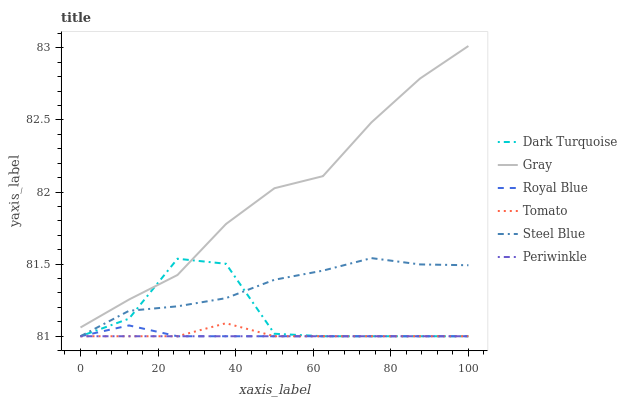Does Periwinkle have the minimum area under the curve?
Answer yes or no. Yes. Does Gray have the maximum area under the curve?
Answer yes or no. Yes. Does Dark Turquoise have the minimum area under the curve?
Answer yes or no. No. Does Dark Turquoise have the maximum area under the curve?
Answer yes or no. No. Is Periwinkle the smoothest?
Answer yes or no. Yes. Is Dark Turquoise the roughest?
Answer yes or no. Yes. Is Gray the smoothest?
Answer yes or no. No. Is Gray the roughest?
Answer yes or no. No. Does Tomato have the lowest value?
Answer yes or no. Yes. Does Gray have the lowest value?
Answer yes or no. No. Does Gray have the highest value?
Answer yes or no. Yes. Does Dark Turquoise have the highest value?
Answer yes or no. No. Is Royal Blue less than Gray?
Answer yes or no. Yes. Is Gray greater than Royal Blue?
Answer yes or no. Yes. Does Dark Turquoise intersect Periwinkle?
Answer yes or no. Yes. Is Dark Turquoise less than Periwinkle?
Answer yes or no. No. Is Dark Turquoise greater than Periwinkle?
Answer yes or no. No. Does Royal Blue intersect Gray?
Answer yes or no. No. 